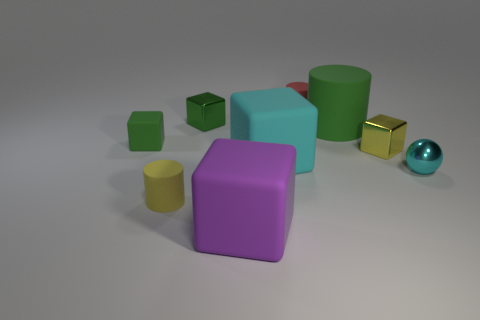What textures are visible in the objects? Most of the objects have a matte finish, providing a smooth and non-reflective texture. However, the small sphere has a shiny, reflective surface that stands out among the other objects. 